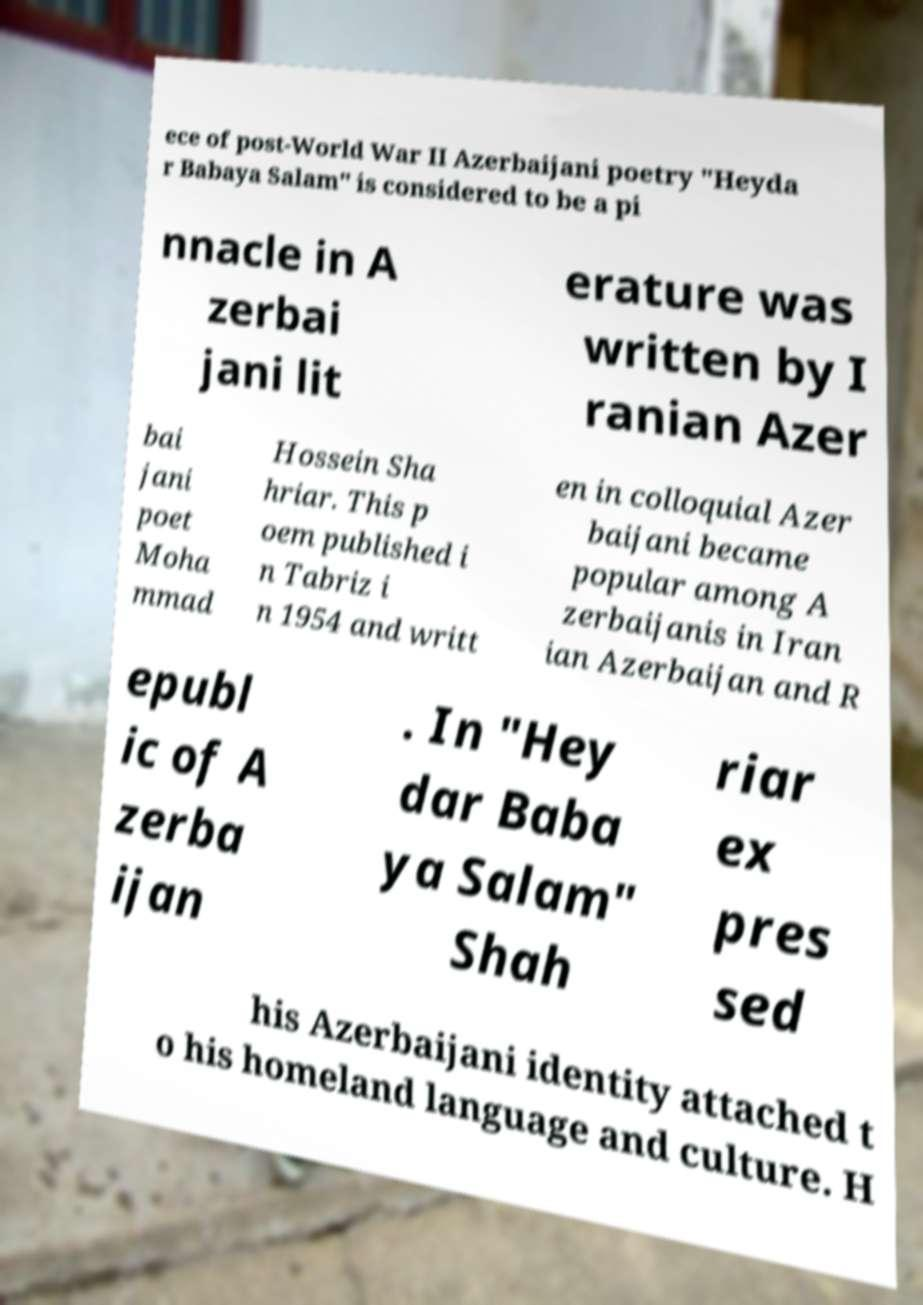For documentation purposes, I need the text within this image transcribed. Could you provide that? ece of post-World War II Azerbaijani poetry "Heyda r Babaya Salam" is considered to be a pi nnacle in A zerbai jani lit erature was written by I ranian Azer bai jani poet Moha mmad Hossein Sha hriar. This p oem published i n Tabriz i n 1954 and writt en in colloquial Azer baijani became popular among A zerbaijanis in Iran ian Azerbaijan and R epubl ic of A zerba ijan . In "Hey dar Baba ya Salam" Shah riar ex pres sed his Azerbaijani identity attached t o his homeland language and culture. H 